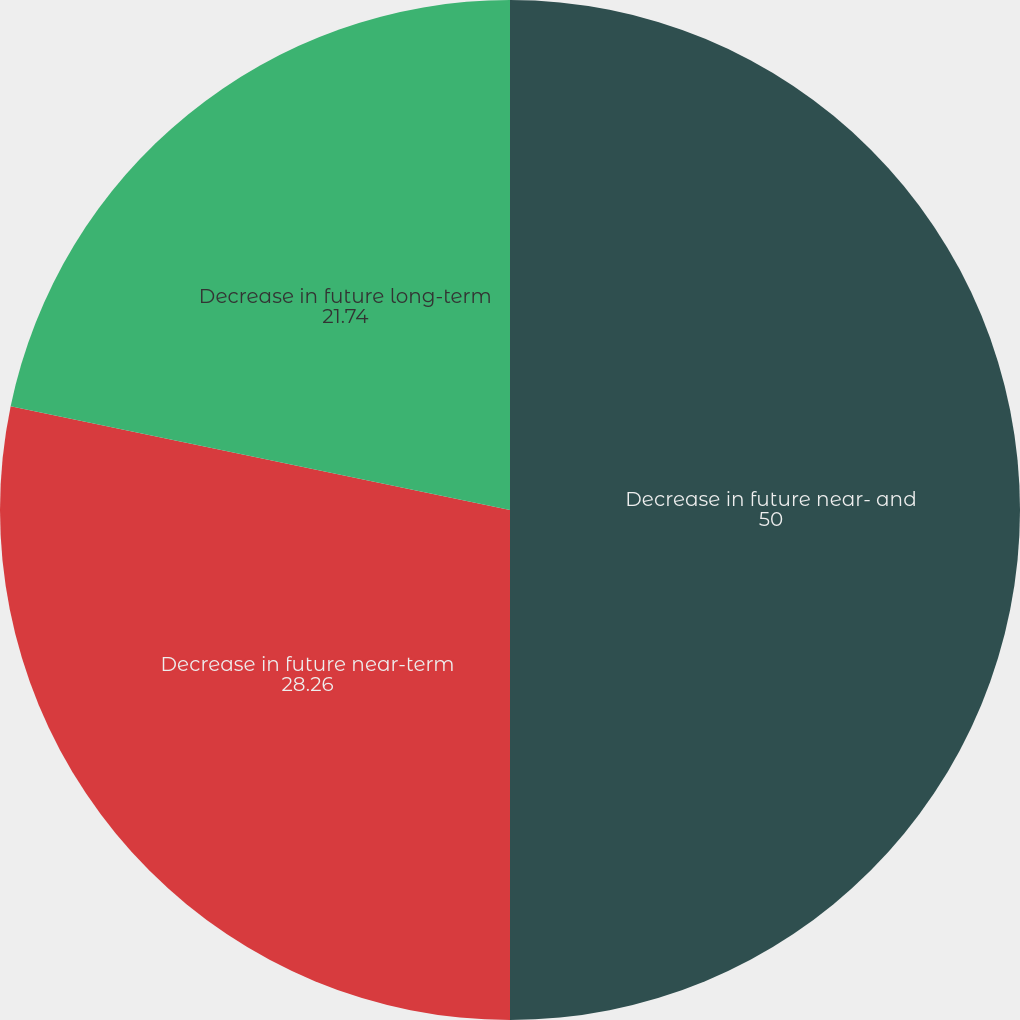Convert chart. <chart><loc_0><loc_0><loc_500><loc_500><pie_chart><fcel>Decrease in future near- and<fcel>Decrease in future near-term<fcel>Decrease in future long-term<nl><fcel>50.0%<fcel>28.26%<fcel>21.74%<nl></chart> 